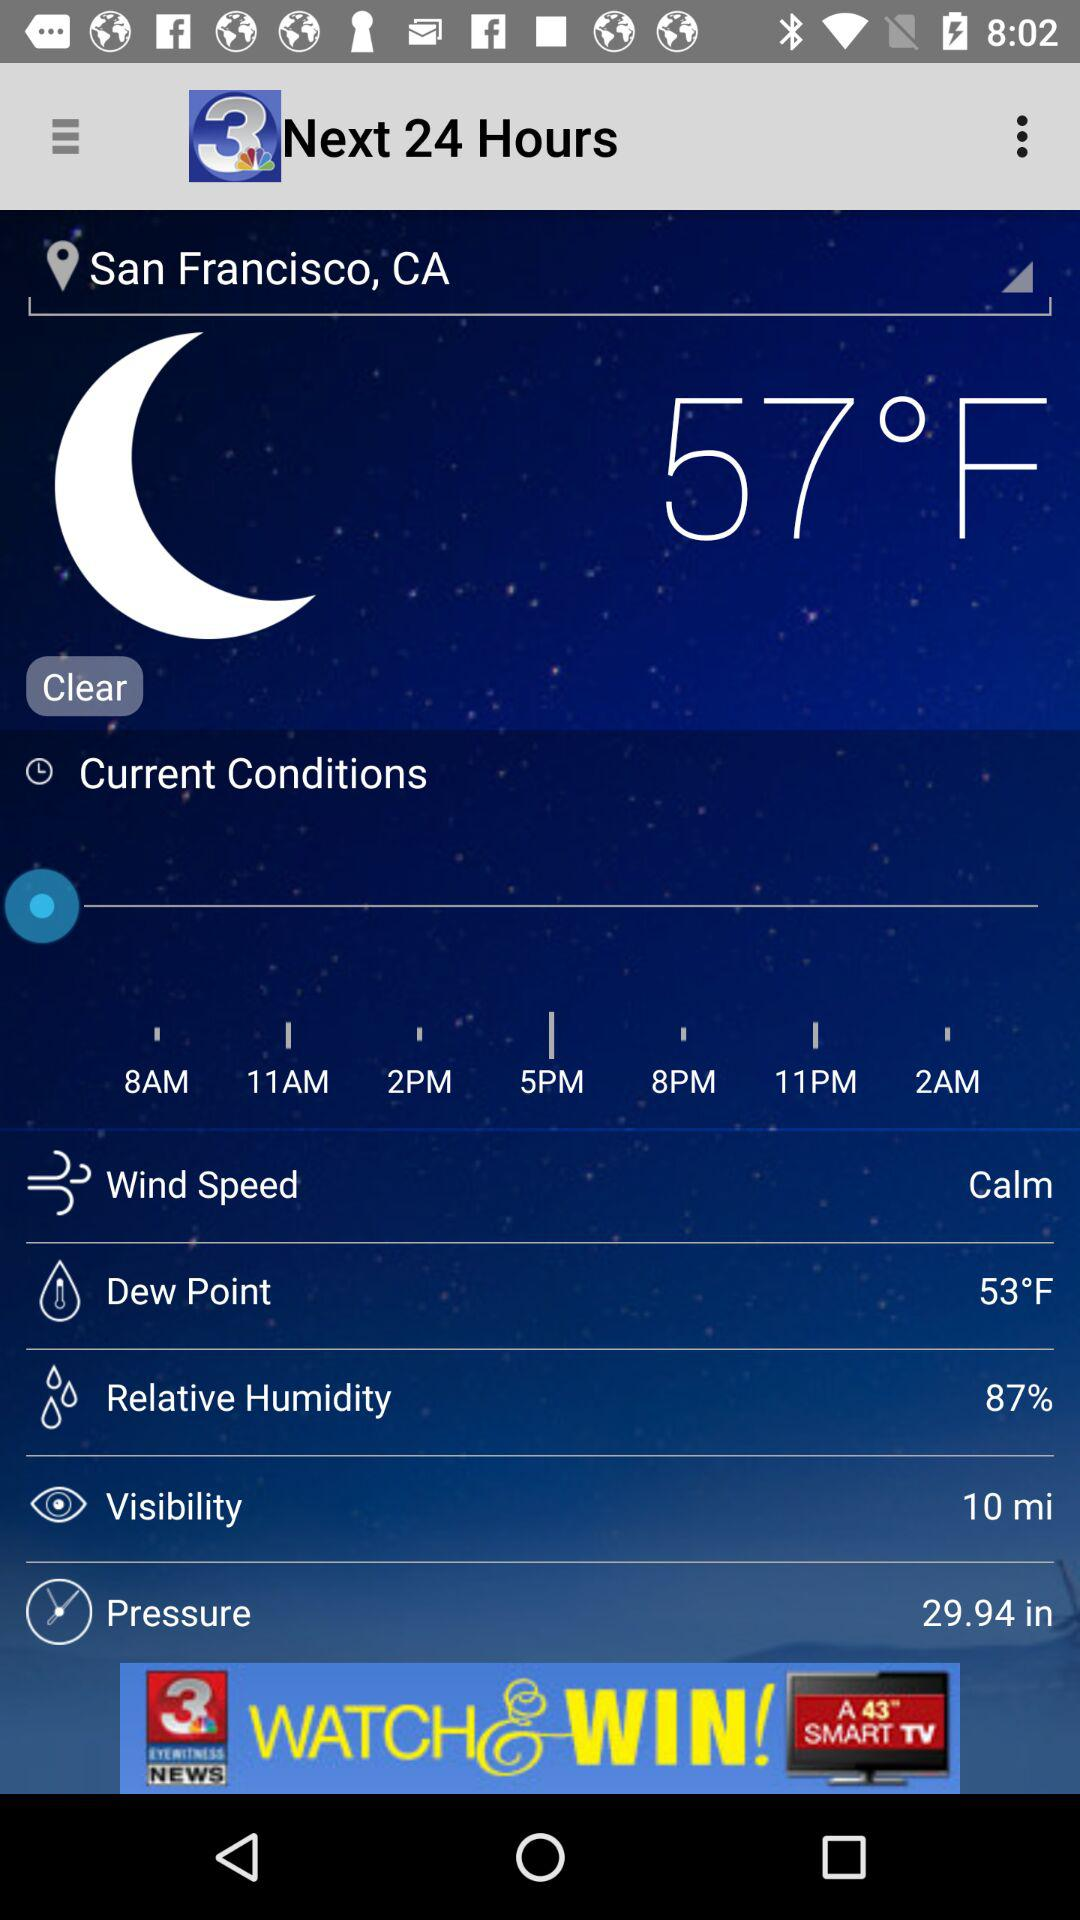What is the visibility? The visibility is 10 miles. 